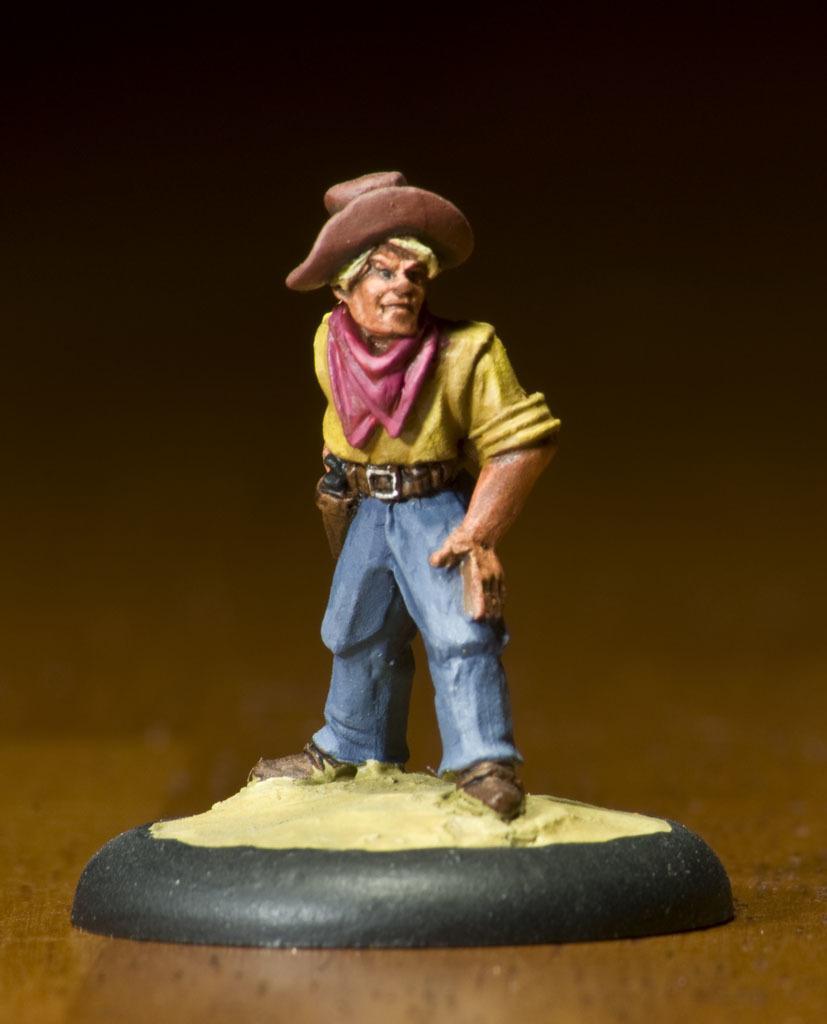How would you summarize this image in a sentence or two? In the image we can see there is a statue of a man kept on the table. There is a scarf on the neck and hat on the man's statute. 